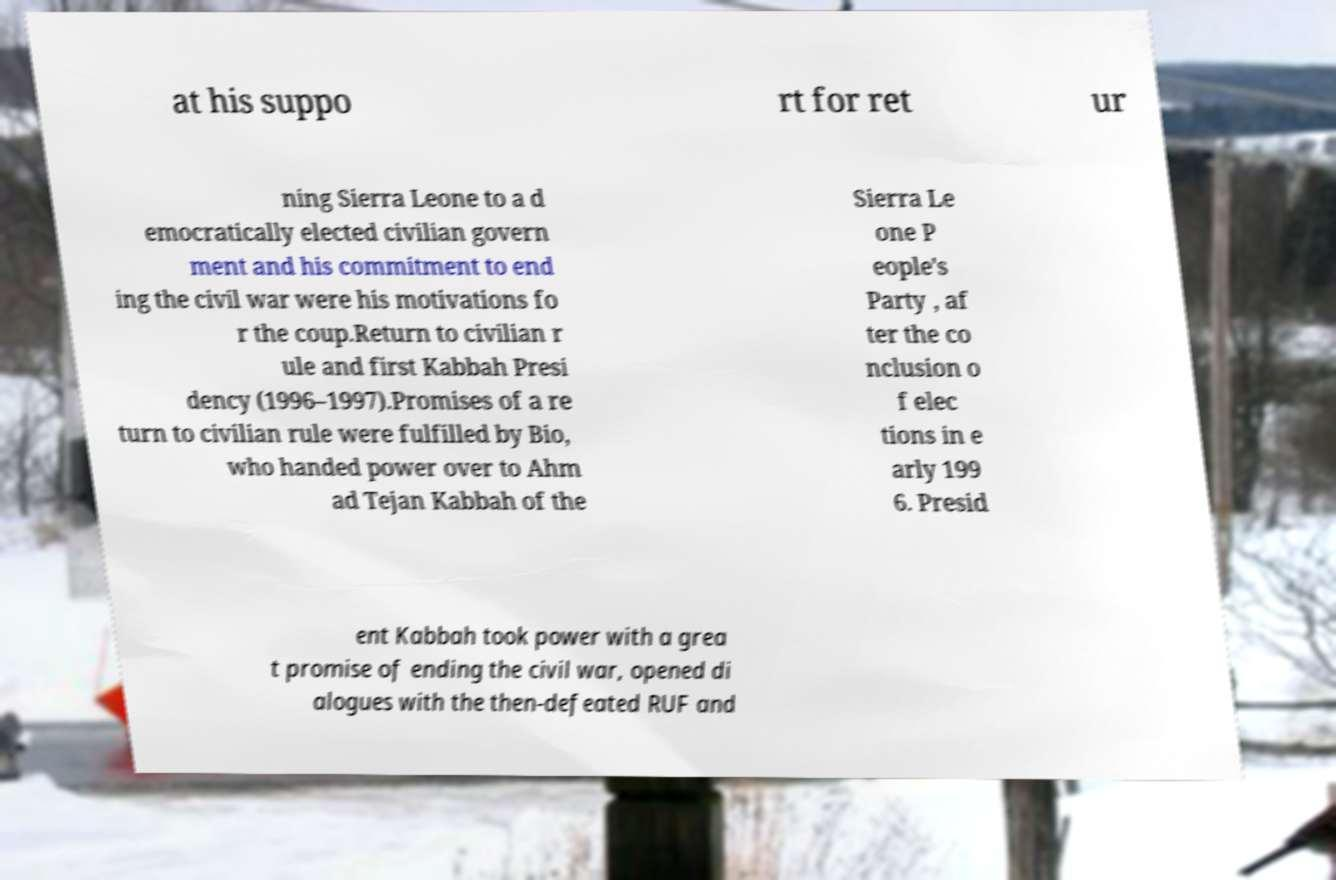Can you accurately transcribe the text from the provided image for me? at his suppo rt for ret ur ning Sierra Leone to a d emocratically elected civilian govern ment and his commitment to end ing the civil war were his motivations fo r the coup.Return to civilian r ule and first Kabbah Presi dency (1996–1997).Promises of a re turn to civilian rule were fulfilled by Bio, who handed power over to Ahm ad Tejan Kabbah of the Sierra Le one P eople's Party , af ter the co nclusion o f elec tions in e arly 199 6. Presid ent Kabbah took power with a grea t promise of ending the civil war, opened di alogues with the then-defeated RUF and 